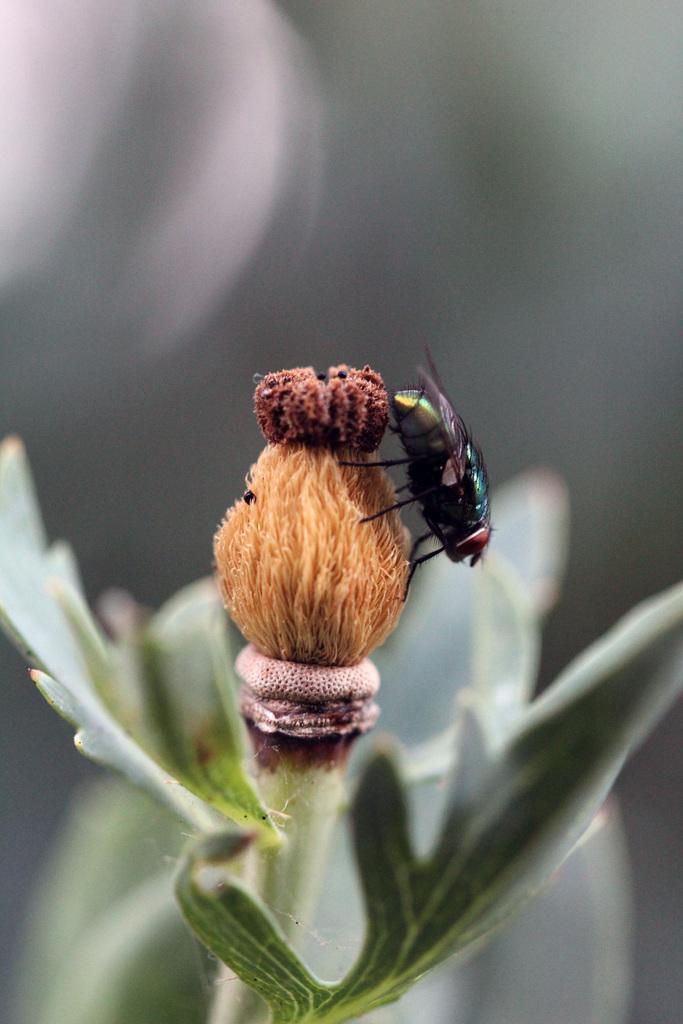Can you describe this image briefly? In the picture we can see some plant with a leaf and a flower bud and on it we can see a house fly with wings. 